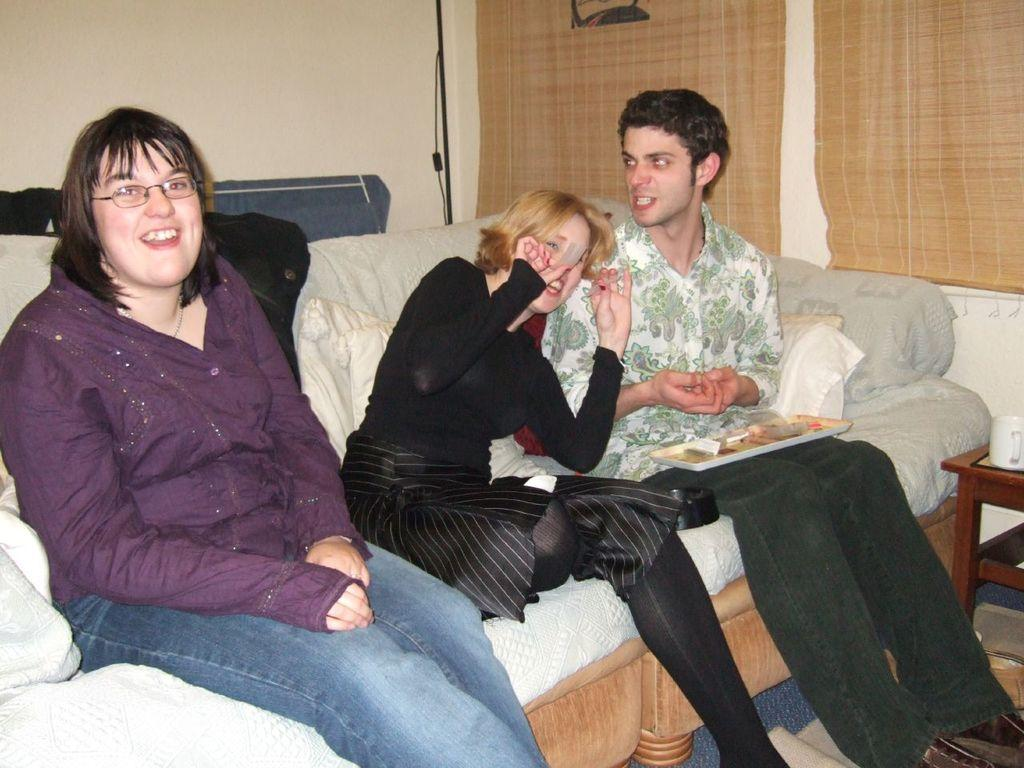How many people are in the image? There are people in the image, but the exact number is not specified. What are the people doing in the image? The people are sitting on a sofa in the image. What type of carriage is being pulled by the pet in the image? There is no carriage or pet present in the image; it only features people sitting on a sofa. 